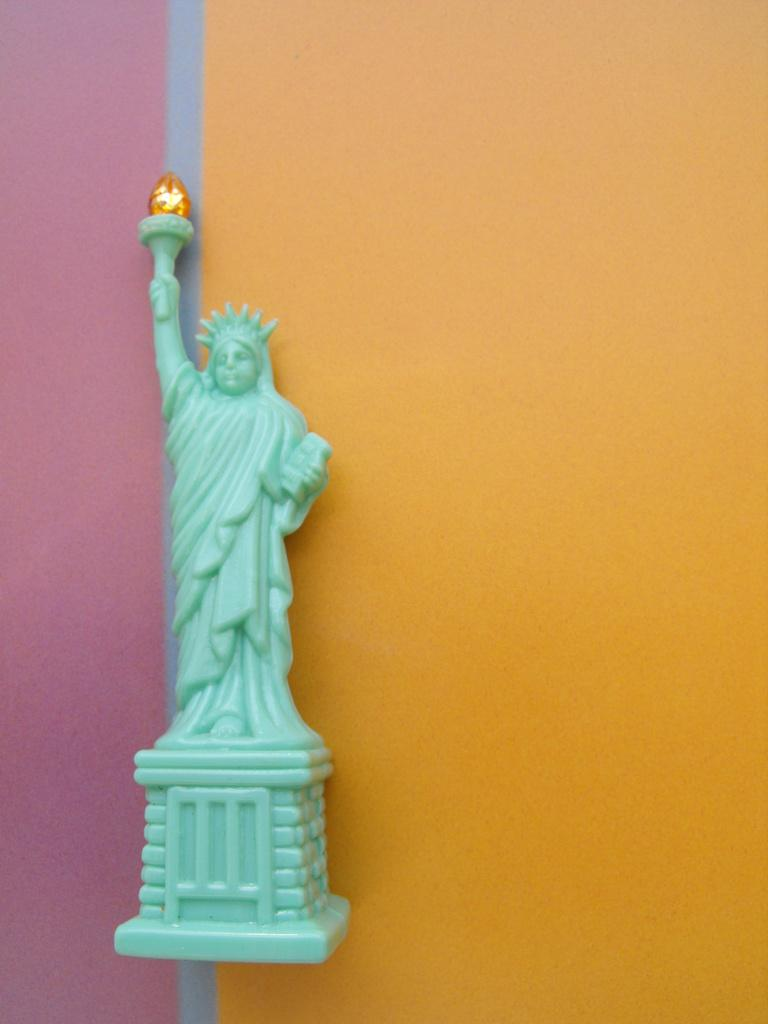What is the main subject in the center of the image? There is a statue in the image, and it is in the middle of the image. How is the statue positioned in relation to its surroundings? The statue is attached to a wall. What type of vegetable is growing out of the statue's mouth in the image? There is no vegetable growing out of the statue's mouth in the image, as the statue does not have a mouth. 